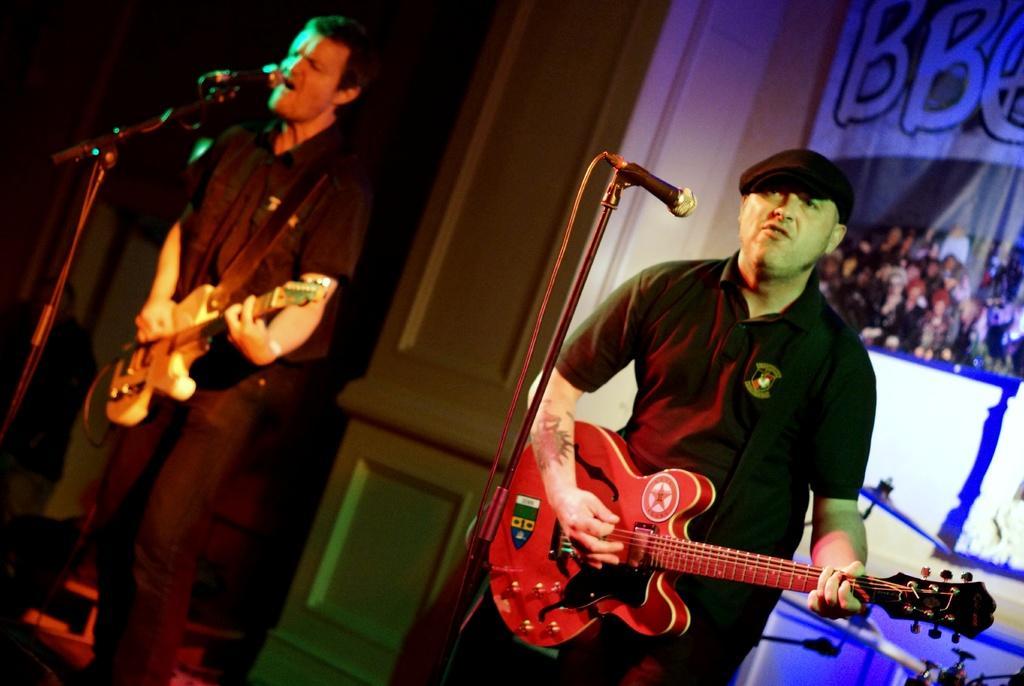Could you give a brief overview of what you see in this image? In this picture we can see two man holding guitars in their hands and playing it and singing on mics and in background we can see wall, banner, drums. 